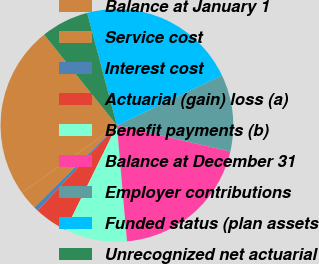Convert chart to OTSL. <chart><loc_0><loc_0><loc_500><loc_500><pie_chart><fcel>Balance at January 1<fcel>Service cost<fcel>Interest cost<fcel>Actuarial (gain) loss (a)<fcel>Benefit payments (b)<fcel>Balance at December 31<fcel>Employer contributions<fcel>Funded status (plan assets<fcel>Unrecognized net actuarial<nl><fcel>24.04%<fcel>2.64%<fcel>0.64%<fcel>4.65%<fcel>8.65%<fcel>20.03%<fcel>10.66%<fcel>22.04%<fcel>6.65%<nl></chart> 